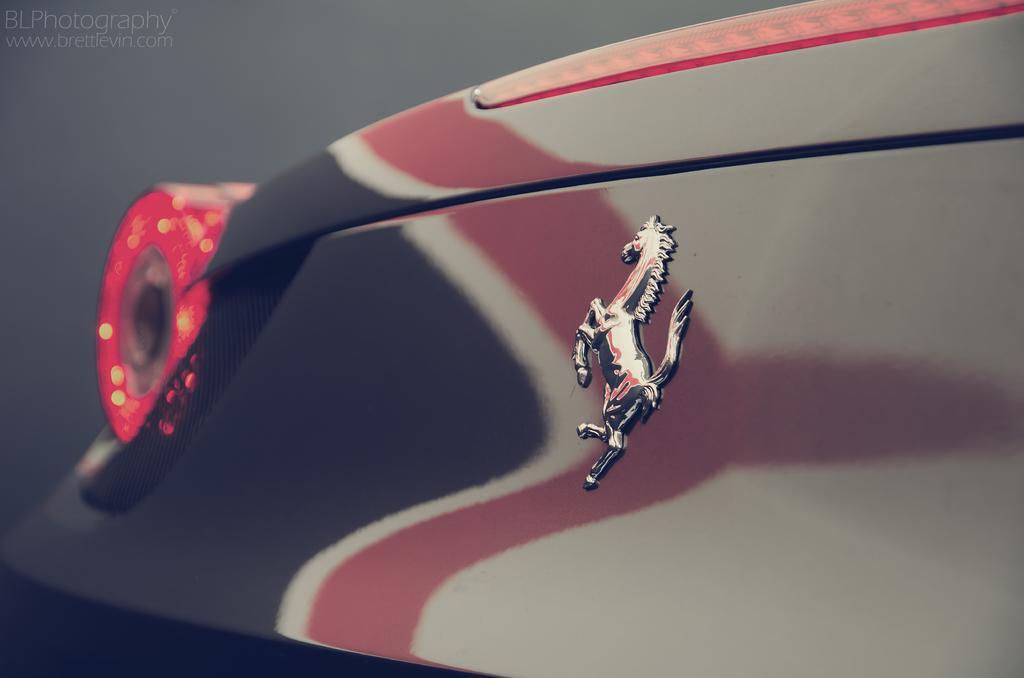How would you summarize this image in a sentence or two? Here I can see a part of the the car. On the left side, I can see a red color light to the car and there is a logo is attached to this car. On the left top of the image I can see some text. 